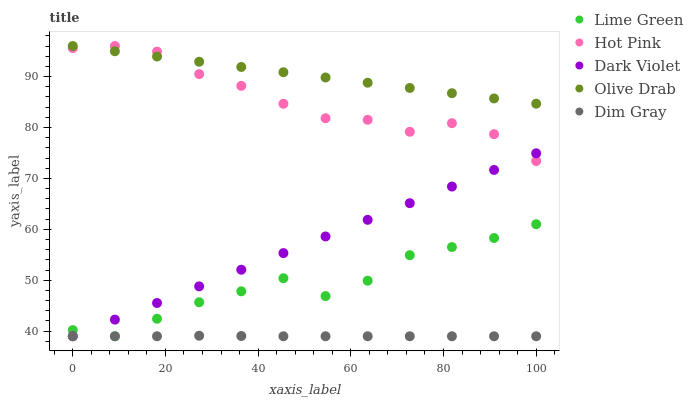Does Dim Gray have the minimum area under the curve?
Answer yes or no. Yes. Does Olive Drab have the maximum area under the curve?
Answer yes or no. Yes. Does Hot Pink have the minimum area under the curve?
Answer yes or no. No. Does Hot Pink have the maximum area under the curve?
Answer yes or no. No. Is Dark Violet the smoothest?
Answer yes or no. Yes. Is Lime Green the roughest?
Answer yes or no. Yes. Is Hot Pink the smoothest?
Answer yes or no. No. Is Hot Pink the roughest?
Answer yes or no. No. Does Dim Gray have the lowest value?
Answer yes or no. Yes. Does Hot Pink have the lowest value?
Answer yes or no. No. Does Olive Drab have the highest value?
Answer yes or no. Yes. Does Lime Green have the highest value?
Answer yes or no. No. Is Dim Gray less than Hot Pink?
Answer yes or no. Yes. Is Hot Pink greater than Lime Green?
Answer yes or no. Yes. Does Hot Pink intersect Olive Drab?
Answer yes or no. Yes. Is Hot Pink less than Olive Drab?
Answer yes or no. No. Is Hot Pink greater than Olive Drab?
Answer yes or no. No. Does Dim Gray intersect Hot Pink?
Answer yes or no. No. 